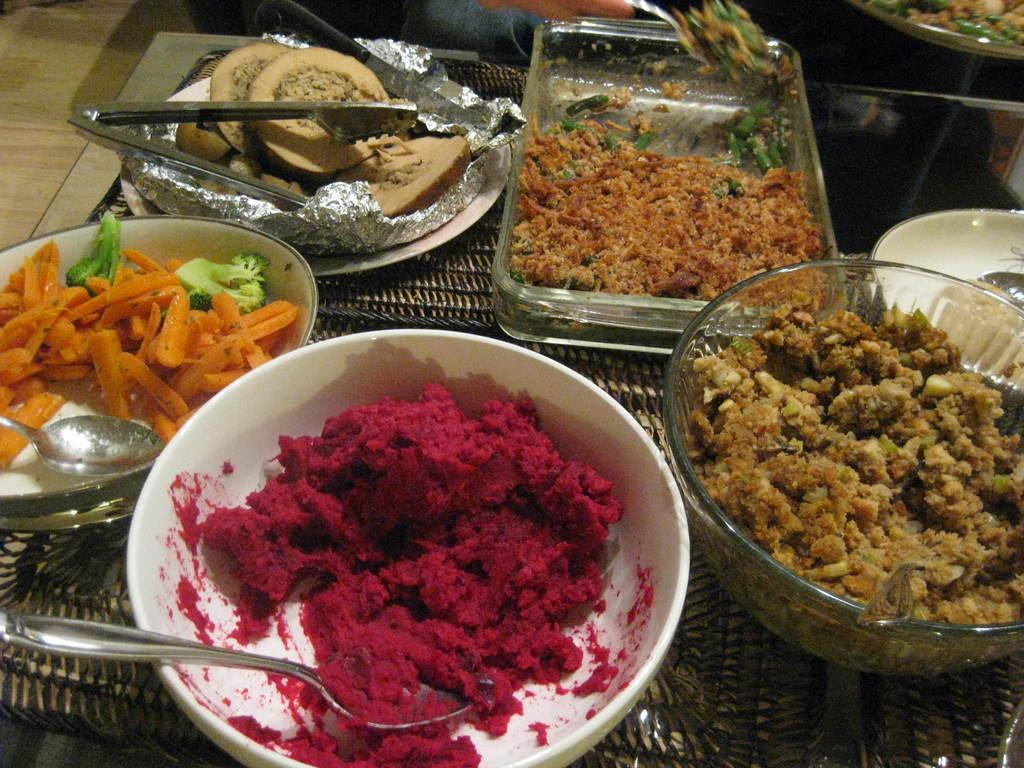What type of dishware is present in the image? There are bowls and plates in the image. What can be used to serve or carry the dishes in the image? There is a tray in the image. What is on the bowls and plates? Food items are present on the plates and bowls. What utensils are visible in the image? Spoons are visible in the image. What is used to cover or protect the food in the image? There is an aluminum foil in the image. What does the dad say about the shape of the food in the image? There is no dad present in the image, and therefore no comment about the shape of the food can be made. 